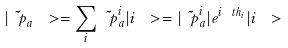Convert formula to latex. <formula><loc_0><loc_0><loc_500><loc_500>| \tilde { \ p } _ { a } \ > = \sum _ { i } \tilde { \ p } _ { a } ^ { i } | i \ > = | \tilde { \ p } _ { a } ^ { i } | e ^ { i \ t h _ { i } } | i \ ></formula> 